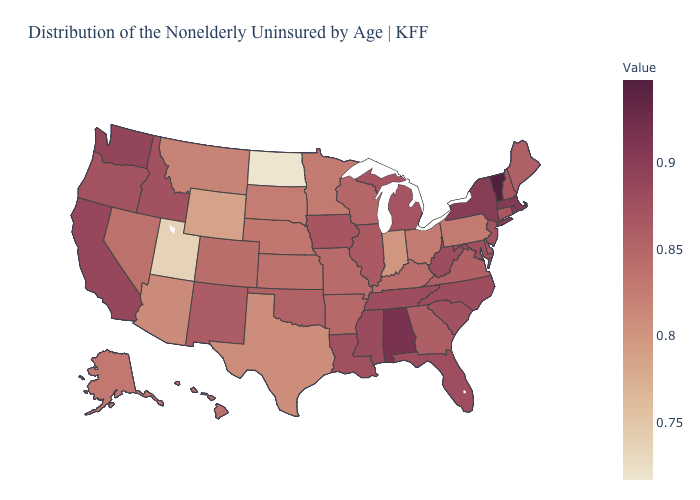Does the map have missing data?
Keep it brief. No. Is the legend a continuous bar?
Write a very short answer. Yes. Does Vermont have the highest value in the Northeast?
Answer briefly. Yes. Does the map have missing data?
Write a very short answer. No. Which states have the lowest value in the USA?
Quick response, please. North Dakota. Does Vermont have the highest value in the USA?
Give a very brief answer. Yes. Does the map have missing data?
Concise answer only. No. Does New Mexico have the lowest value in the West?
Keep it brief. No. Does Oklahoma have a lower value than Wyoming?
Be succinct. No. Is the legend a continuous bar?
Give a very brief answer. Yes. 